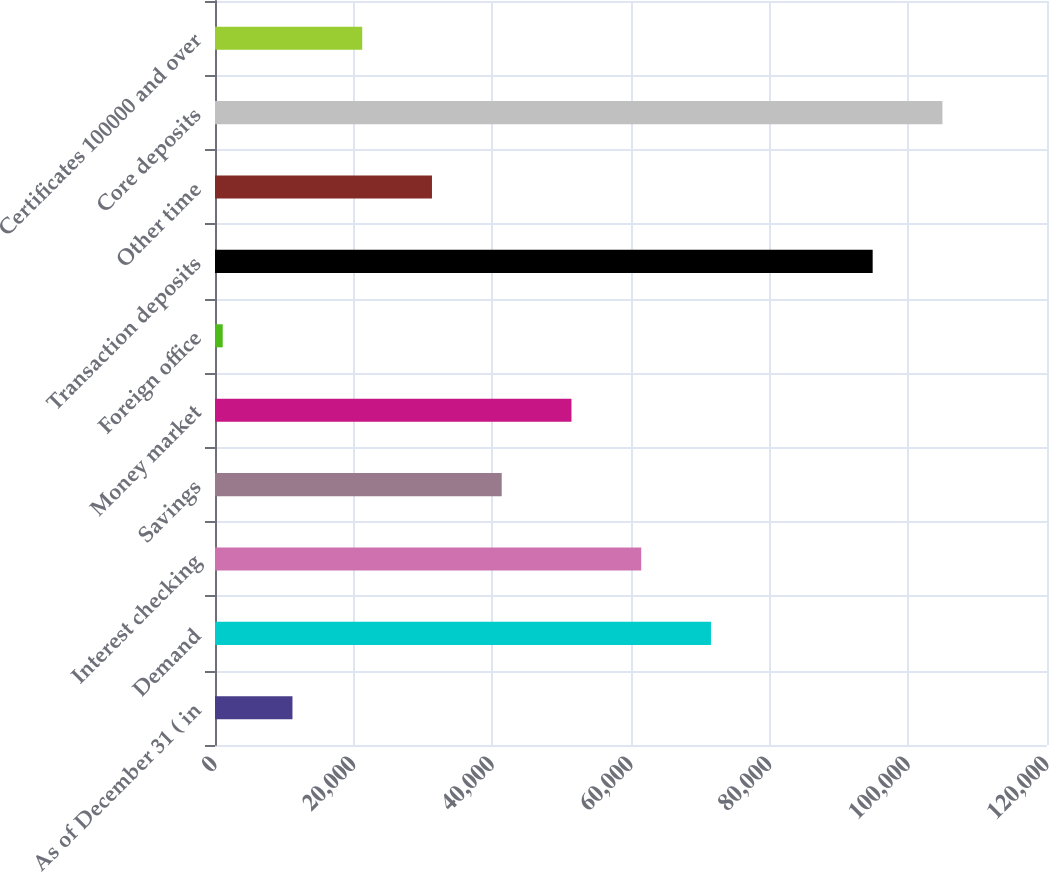<chart> <loc_0><loc_0><loc_500><loc_500><bar_chart><fcel>As of December 31 ( in<fcel>Demand<fcel>Interest checking<fcel>Savings<fcel>Money market<fcel>Foreign office<fcel>Transaction deposits<fcel>Other time<fcel>Core deposits<fcel>Certificates 100000 and over<nl><fcel>11173.8<fcel>71532.6<fcel>61472.8<fcel>41353.2<fcel>51413<fcel>1114<fcel>94857<fcel>31293.4<fcel>104917<fcel>21233.6<nl></chart> 